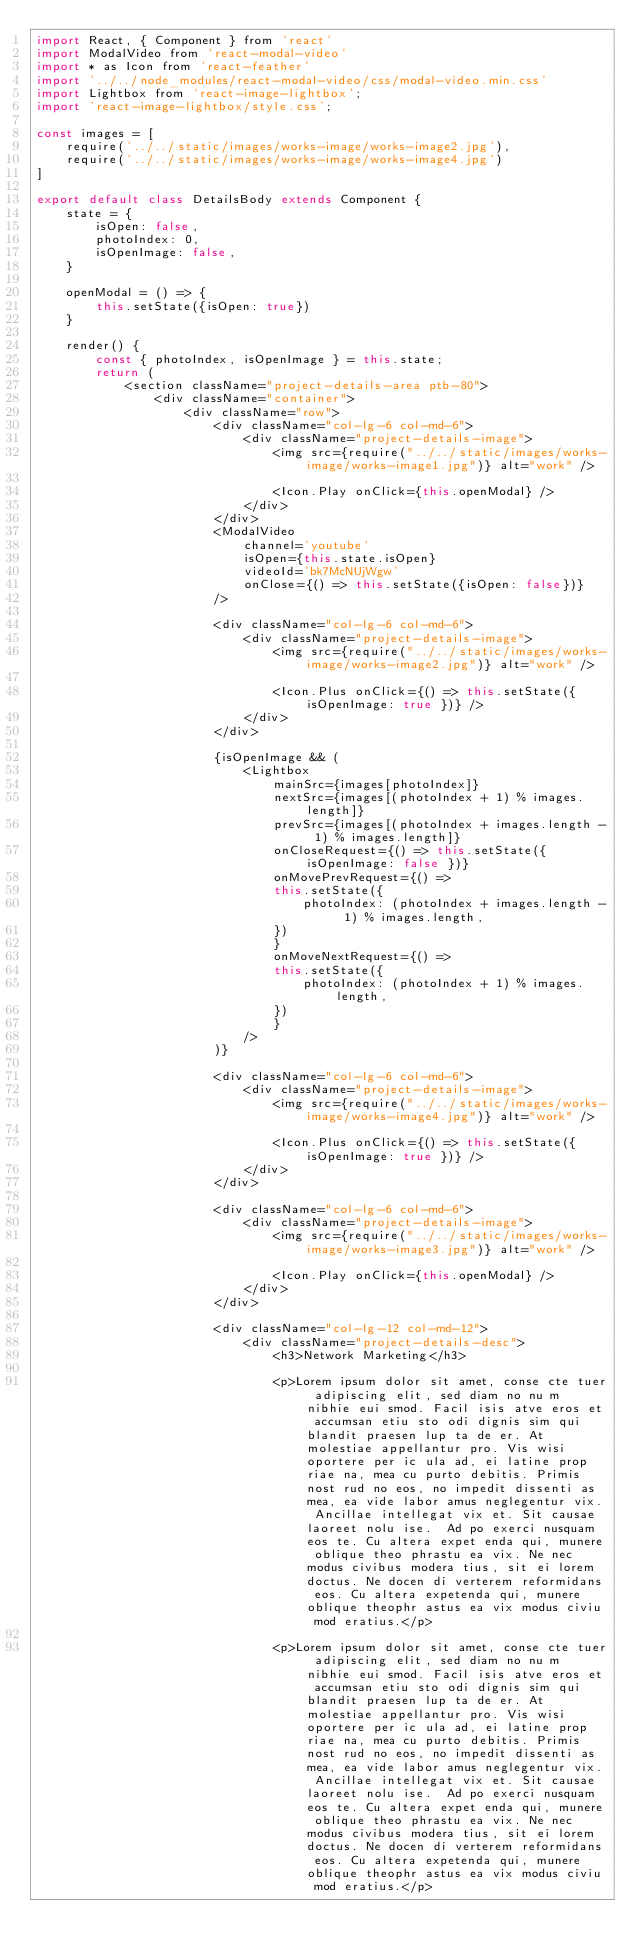<code> <loc_0><loc_0><loc_500><loc_500><_JavaScript_>import React, { Component } from 'react'
import ModalVideo from 'react-modal-video'
import * as Icon from 'react-feather'
import '../../node_modules/react-modal-video/css/modal-video.min.css'
import Lightbox from 'react-image-lightbox';
import 'react-image-lightbox/style.css';

const images = [
    require('../../static/images/works-image/works-image2.jpg'),
    require('../../static/images/works-image/works-image4.jpg')
]

export default class DetailsBody extends Component {
    state = {
        isOpen: false,
        photoIndex: 0,
        isOpenImage: false,
    }

    openModal = () => {
        this.setState({isOpen: true})
    }

    render() {
        const { photoIndex, isOpenImage } = this.state;
        return (
            <section className="project-details-area ptb-80">
                <div className="container">
                    <div className="row">
                        <div className="col-lg-6 col-md-6">
                            <div className="project-details-image">
                                <img src={require("../../static/images/works-image/works-image1.jpg")} alt="work" />

                                <Icon.Play onClick={this.openModal} />
                            </div>
                        </div>
                        <ModalVideo 
                            channel='youtube' 
                            isOpen={this.state.isOpen} 
                            videoId='bk7McNUjWgw' 
                            onClose={() => this.setState({isOpen: false})} 
                        />

                        <div className="col-lg-6 col-md-6">
                            <div className="project-details-image">
                                <img src={require("../../static/images/works-image/works-image2.jpg")} alt="work" />

                                <Icon.Plus onClick={() => this.setState({ isOpenImage: true })} />
                            </div>
                        </div>

                        {isOpenImage && (
                            <Lightbox
                                mainSrc={images[photoIndex]}
                                nextSrc={images[(photoIndex + 1) % images.length]}
                                prevSrc={images[(photoIndex + images.length - 1) % images.length]}
                                onCloseRequest={() => this.setState({ isOpenImage: false })}
                                onMovePrevRequest={() =>
                                this.setState({
                                    photoIndex: (photoIndex + images.length - 1) % images.length,
                                })
                                }
                                onMoveNextRequest={() =>
                                this.setState({
                                    photoIndex: (photoIndex + 1) % images.length,
                                })
                                }
                            />
                        )}

                        <div className="col-lg-6 col-md-6">
                            <div className="project-details-image">
                                <img src={require("../../static/images/works-image/works-image4.jpg")} alt="work" />

                                <Icon.Plus onClick={() => this.setState({ isOpenImage: true })} />
                            </div>
                        </div>

                        <div className="col-lg-6 col-md-6">
                            <div className="project-details-image">
                                <img src={require("../../static/images/works-image/works-image3.jpg")} alt="work" />

                                <Icon.Play onClick={this.openModal} />
                            </div>
                        </div>

                        <div className="col-lg-12 col-md-12">
                            <div className="project-details-desc">
                                <h3>Network Marketing</h3>
                                
                                <p>Lorem ipsum dolor sit amet, conse cte tuer adipiscing elit, sed diam no nu m nibhie eui smod. Facil isis atve eros et accumsan etiu sto odi dignis sim qui blandit praesen lup ta de er. At molestiae appellantur pro. Vis wisi oportere per ic ula ad, ei latine prop riae na, mea cu purto debitis. Primis nost rud no eos, no impedit dissenti as mea, ea vide labor amus neglegentur vix. Ancillae intellegat vix et. Sit causae laoreet nolu ise.  Ad po exerci nusquam eos te. Cu altera expet enda qui, munere oblique theo phrastu ea vix. Ne nec modus civibus modera tius, sit ei lorem doctus. Ne docen di verterem reformidans eos. Cu altera expetenda qui, munere oblique theophr astus ea vix modus civiu mod eratius.</p>

                                <p>Lorem ipsum dolor sit amet, conse cte tuer adipiscing elit, sed diam no nu m nibhie eui smod. Facil isis atve eros et accumsan etiu sto odi dignis sim qui blandit praesen lup ta de er. At molestiae appellantur pro. Vis wisi oportere per ic ula ad, ei latine prop riae na, mea cu purto debitis. Primis nost rud no eos, no impedit dissenti as mea, ea vide labor amus neglegentur vix. Ancillae intellegat vix et. Sit causae laoreet nolu ise.  Ad po exerci nusquam eos te. Cu altera expet enda qui, munere oblique theo phrastu ea vix. Ne nec modus civibus modera tius, sit ei lorem doctus. Ne docen di verterem reformidans eos. Cu altera expetenda qui, munere oblique theophr astus ea vix modus civiu mod eratius.</p>
</code> 